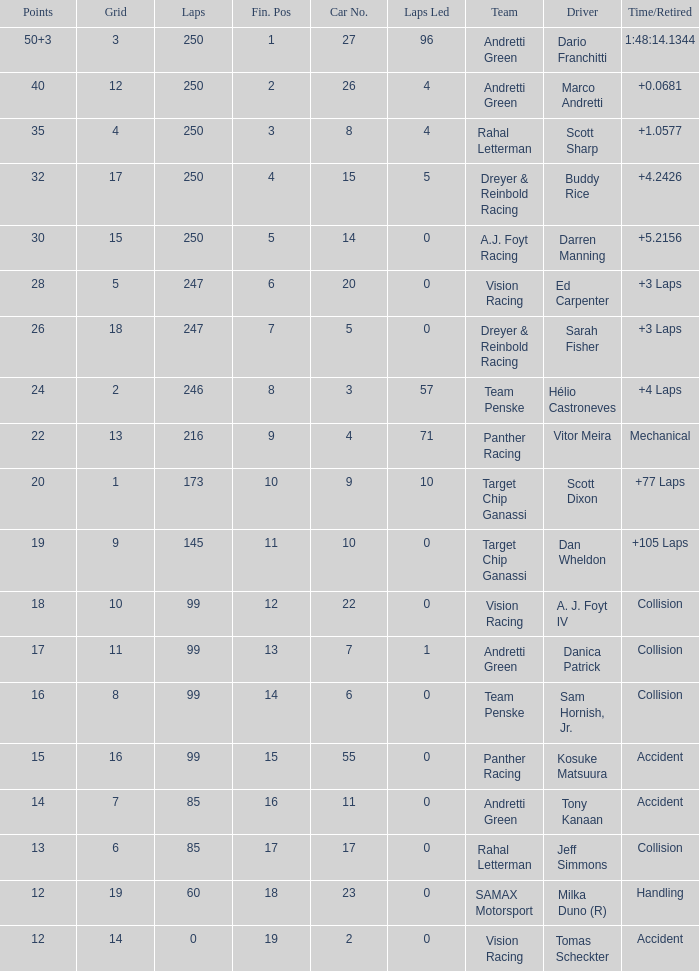What is the grid for the driver who earned 14 points? 7.0. 